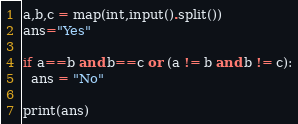Convert code to text. <code><loc_0><loc_0><loc_500><loc_500><_Python_>a,b,c = map(int,input().split())
ans="Yes"

if a==b and b==c or (a != b and b != c):
  ans = "No"
  
print(ans)
</code> 